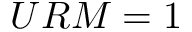<formula> <loc_0><loc_0><loc_500><loc_500>U R M = 1</formula> 